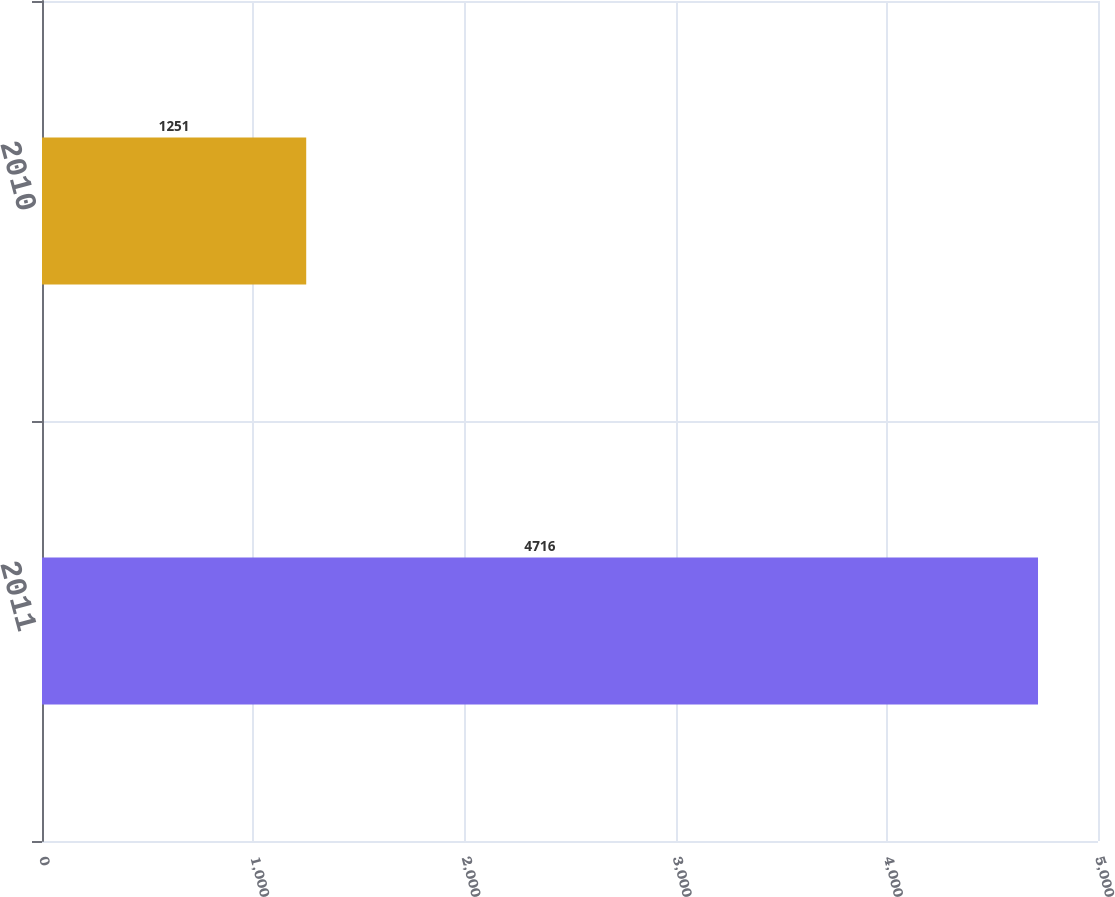Convert chart. <chart><loc_0><loc_0><loc_500><loc_500><bar_chart><fcel>2011<fcel>2010<nl><fcel>4716<fcel>1251<nl></chart> 